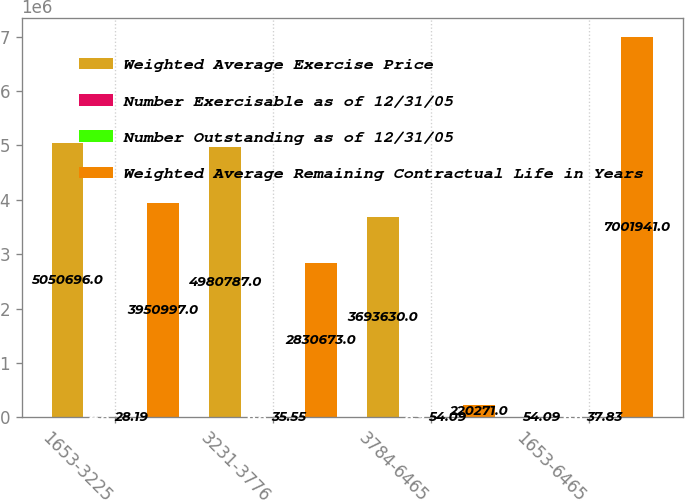<chart> <loc_0><loc_0><loc_500><loc_500><stacked_bar_chart><ecel><fcel>1653-3225<fcel>3231-3776<fcel>3784-6465<fcel>1653-6465<nl><fcel>Weighted Average Exercise Price<fcel>5.0507e+06<fcel>4.98079e+06<fcel>3.69363e+06<fcel>54.09<nl><fcel>Number Exercisable as of 12/31/05<fcel>4.8<fcel>6.8<fcel>8.9<fcel>6.6<nl><fcel>Number Outstanding as of 12/31/05<fcel>28.19<fcel>35.55<fcel>54.09<fcel>37.83<nl><fcel>Weighted Average Remaining Contractual Life in Years<fcel>3.951e+06<fcel>2.83067e+06<fcel>220271<fcel>7.00194e+06<nl></chart> 